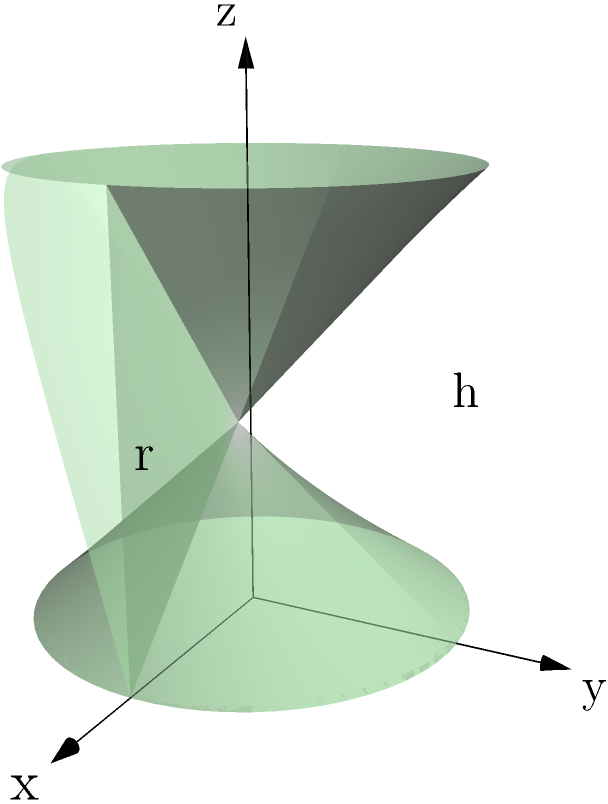As a vegan bakery owner, you're designing a new cylindrical cake tin for a special recipe. The tin has a radius of 6 cm and a height of 15 cm. Calculate the volume of this cake tin to determine how much batter it can hold. Round your answer to the nearest whole number. To calculate the volume of a cylindrical cake tin, we use the formula:

$$V = \pi r^2 h$$

Where:
$V$ = volume
$\pi$ = pi (approximately 3.14159)
$r$ = radius of the base
$h$ = height of the cylinder

Given:
- Radius ($r$) = 6 cm
- Height ($h$) = 15 cm

Let's substitute these values into the formula:

$$V = \pi (6 \text{ cm})^2 (15 \text{ cm})$$

Step 1: Calculate $r^2$
$6^2 = 36$

Step 2: Multiply by $\pi$
$\pi \times 36 = 113.097$

Step 3: Multiply by the height
$113.097 \times 15 = 1,696.46 \text{ cm}^3$

Step 4: Round to the nearest whole number
$1,696.46 \text{ cm}^3 \approx 1,696 \text{ cm}^3$

Therefore, the volume of the cylindrical cake tin is approximately 1,696 cubic centimeters.
Answer: 1,696 cm³ 